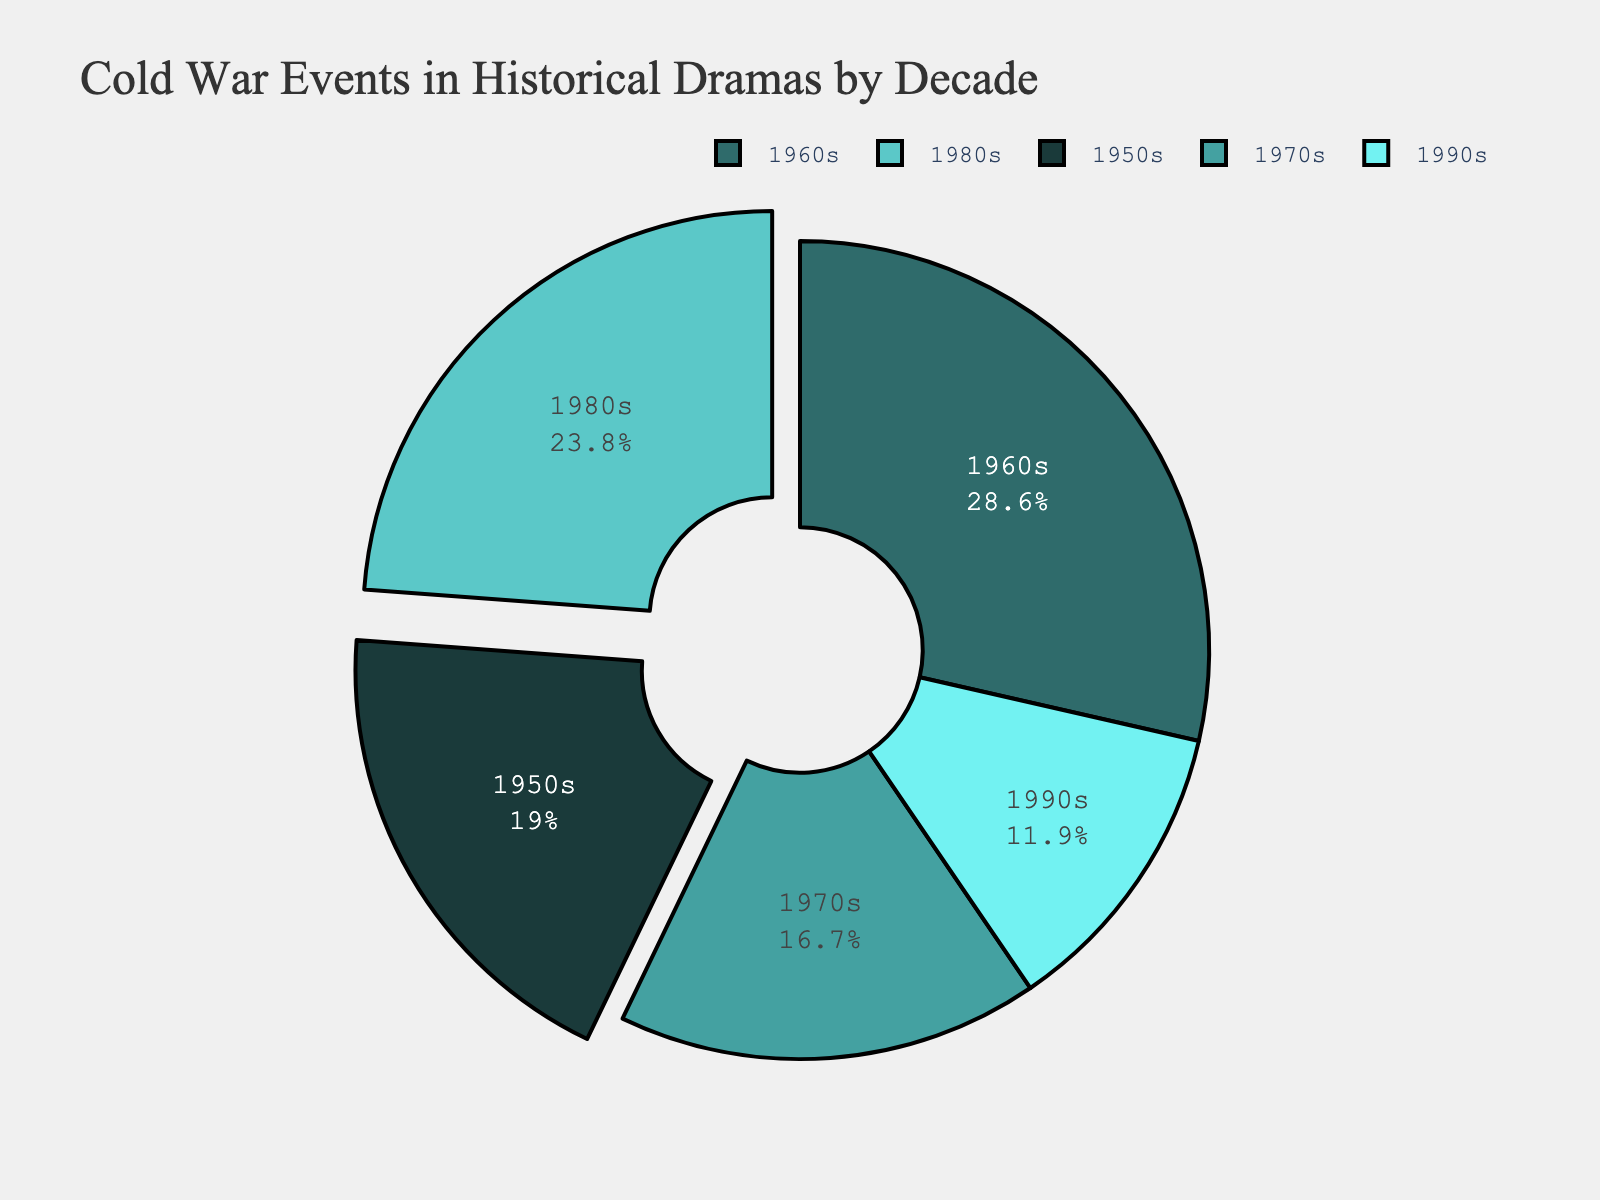What decade had the highest number of Cold War events in historical drama series? To determine the decade with the highest number of Cold War events, we look for the slice with the largest portion and label. The 1960s slice is the largest and corresponds to 12 events.
Answer: 1960s Which decades have an equal number of Cold War events featured? Look for slices with the same size and verify their labels. The 1970s and 1990s slices are the same size with each having 7 events.
Answer: 1970s and 1990s What is the ratio of Cold War events featured in the 1950s to those in the 1980s? Check the labeled slices for the 1950s and 1980s, which reveal 8 and 10 events, respectively. The ratio is 8:10, which simplifies to 4:5.
Answer: 4:5 How many total Cold War events are featured in the 1950s and 1970s combined? Sum the events from the 1950s and 1970s slices: 8 events from the 1950s and 7 from the 1970s, giving a total of 8 + 7.
Answer: 15 What percentage of events featured in the 1990s relative to the total number of events? First, calculate the total number of events: 8 (1950s) + 12 (1960s) + 7 (1970s) + 10 (1980s) + 5 (1990s) = 42 events. Then, find the percentage of the 1990s: (5 / 42) * 100 ≈ 11.9%.
Answer: ~11.9% Which decade experienced an increase in events over its preceding decade? Compare the number of events between consecutive decades. The 1960s (12 events) increased from the 1950s (8 events) and the 1980s (10 events) increased from the 1970s (7 events).
Answer: 1960s and 1980s What is the difference in the number of events between the 1960s and the 1990s? Subtract the number of events in the 1990s from the number in the 1960s: 12 - 5 = 7.
Answer: 7 What are the colors representing the decades in the pie chart? Identify the colors associated with each slice. The 1950s is dark green, the 1960s medium green, the 1970s light green, the 1980s teal, and the 1990s cyan.
Answer: Dark green, medium green, light green, teal, and cyan 